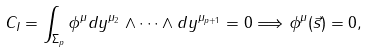Convert formula to latex. <formula><loc_0><loc_0><loc_500><loc_500>C _ { I } = \int _ { \Sigma _ { p } } \phi ^ { \mu } d y ^ { \mu _ { 2 } } \wedge \dots \wedge d y ^ { \mu _ { p + 1 } } = 0 \Longrightarrow \phi ^ { \mu } ( \vec { s } ) = 0 ,</formula> 